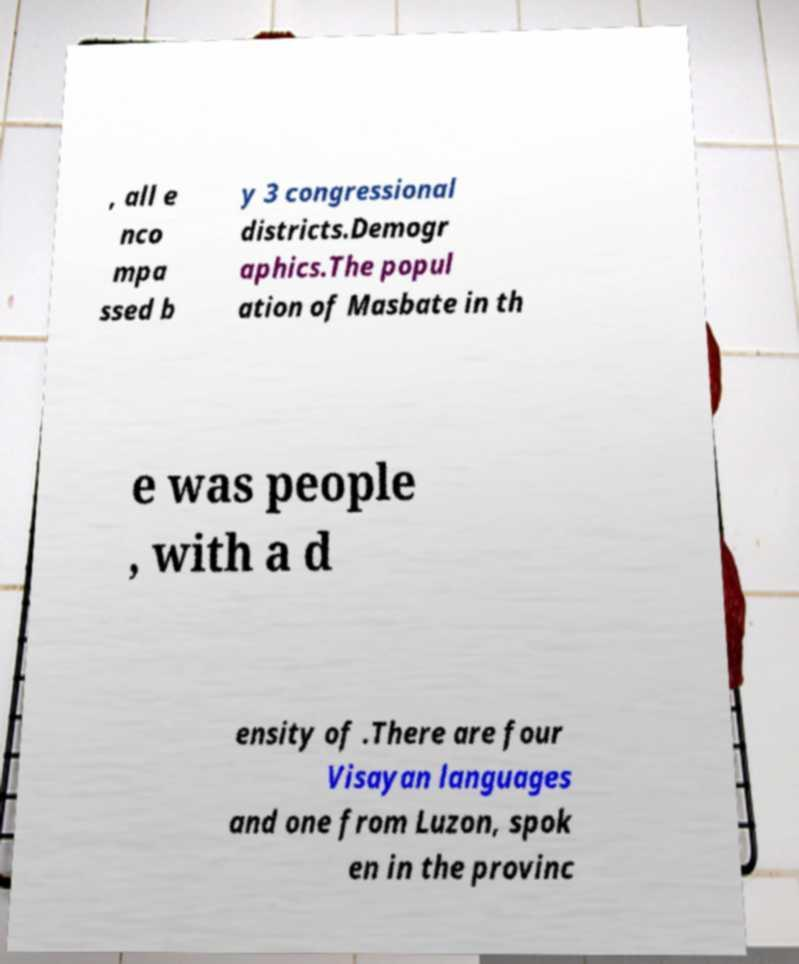Please identify and transcribe the text found in this image. , all e nco mpa ssed b y 3 congressional districts.Demogr aphics.The popul ation of Masbate in th e was people , with a d ensity of .There are four Visayan languages and one from Luzon, spok en in the provinc 